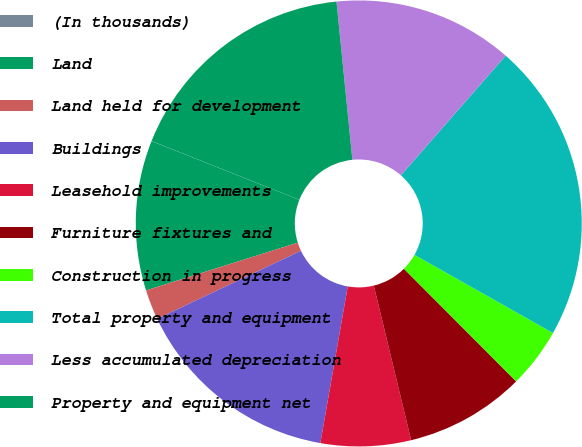Convert chart to OTSL. <chart><loc_0><loc_0><loc_500><loc_500><pie_chart><fcel>(In thousands)<fcel>Land<fcel>Land held for development<fcel>Buildings<fcel>Leasehold improvements<fcel>Furniture fixtures and<fcel>Construction in progress<fcel>Total property and equipment<fcel>Less accumulated depreciation<fcel>Property and equipment net<nl><fcel>0.01%<fcel>10.87%<fcel>2.18%<fcel>15.21%<fcel>6.53%<fcel>8.7%<fcel>4.35%<fcel>21.73%<fcel>13.04%<fcel>17.38%<nl></chart> 